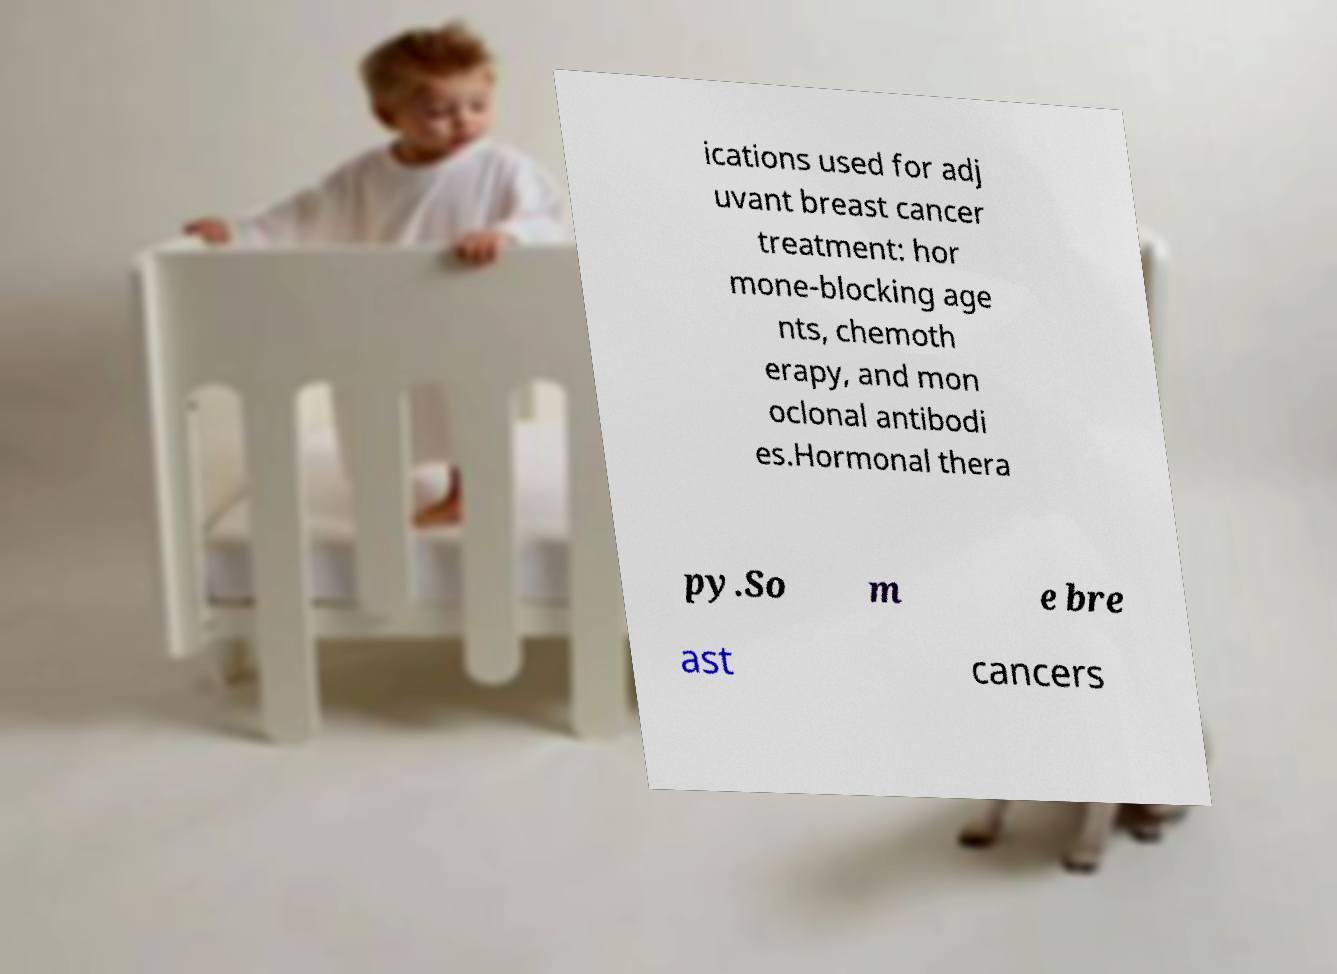There's text embedded in this image that I need extracted. Can you transcribe it verbatim? ications used for adj uvant breast cancer treatment: hor mone-blocking age nts, chemoth erapy, and mon oclonal antibodi es.Hormonal thera py.So m e bre ast cancers 